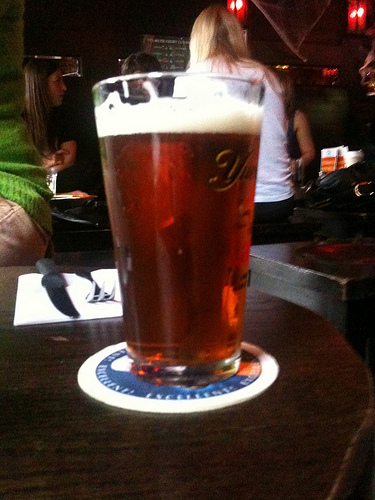<image>
Can you confirm if the glass is on the table? Yes. Looking at the image, I can see the glass is positioned on top of the table, with the table providing support. Is the beer in the glass? Yes. The beer is contained within or inside the glass, showing a containment relationship. 